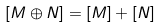<formula> <loc_0><loc_0><loc_500><loc_500>[ M \oplus N ] = [ M ] + [ N ]</formula> 